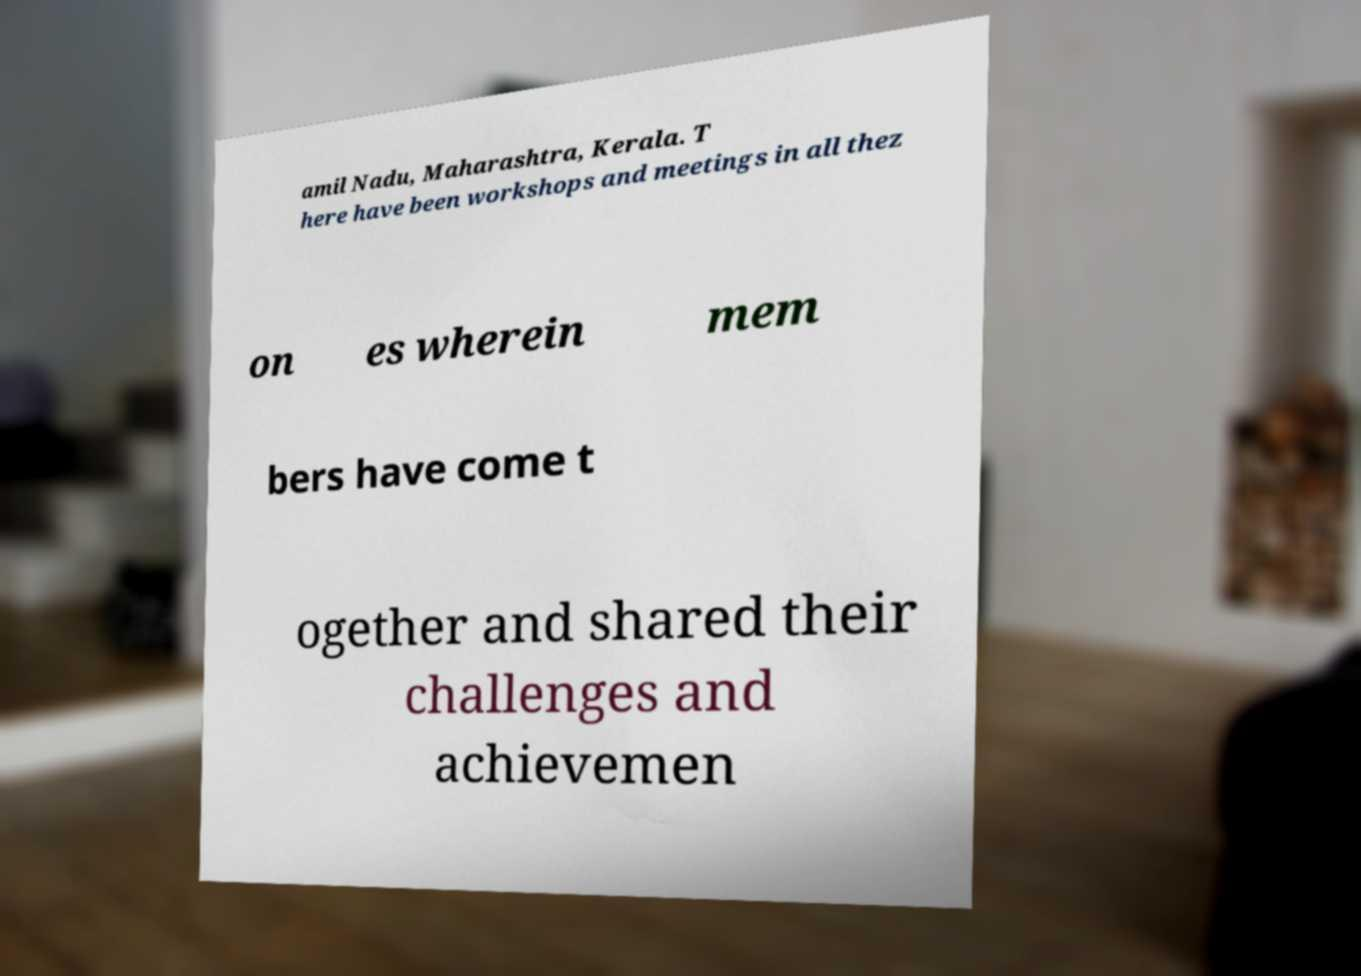Could you extract and type out the text from this image? amil Nadu, Maharashtra, Kerala. T here have been workshops and meetings in all thez on es wherein mem bers have come t ogether and shared their challenges and achievemen 